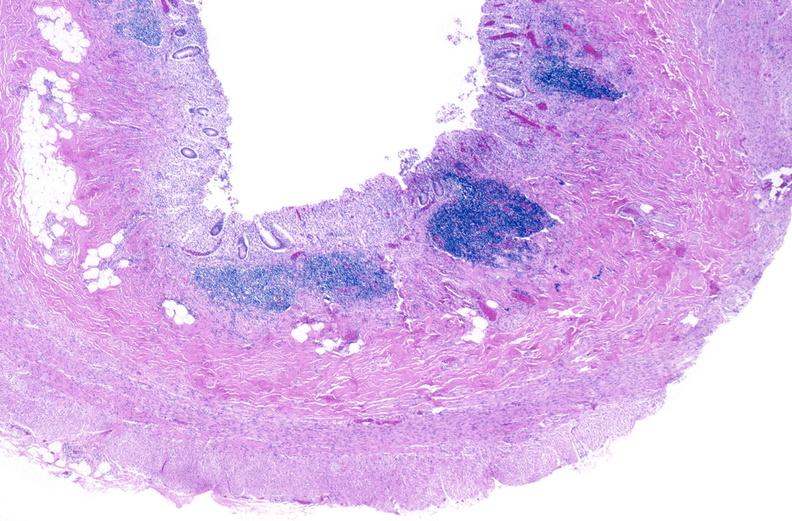what is present?
Answer the question using a single word or phrase. Gastrointestinal 